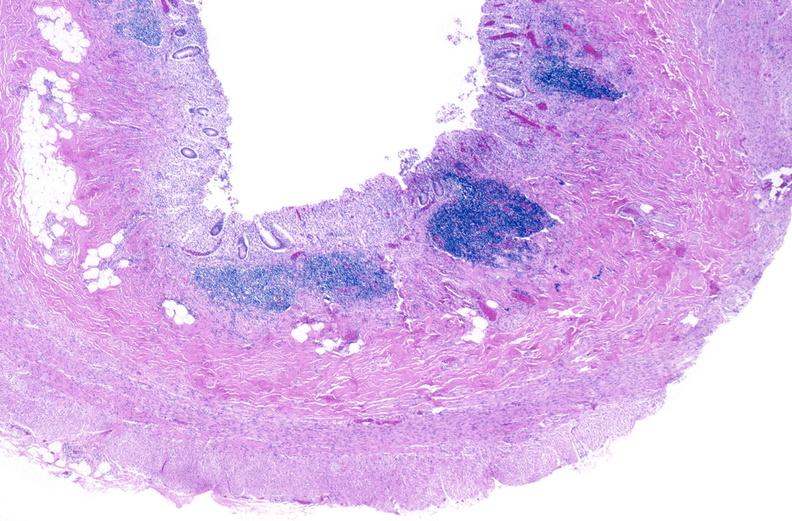what is present?
Answer the question using a single word or phrase. Gastrointestinal 